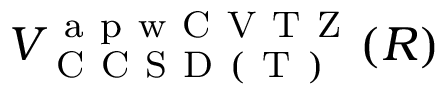<formula> <loc_0><loc_0><loc_500><loc_500>V _ { C C S D ( T ) } ^ { a p w C V T Z } ( R )</formula> 